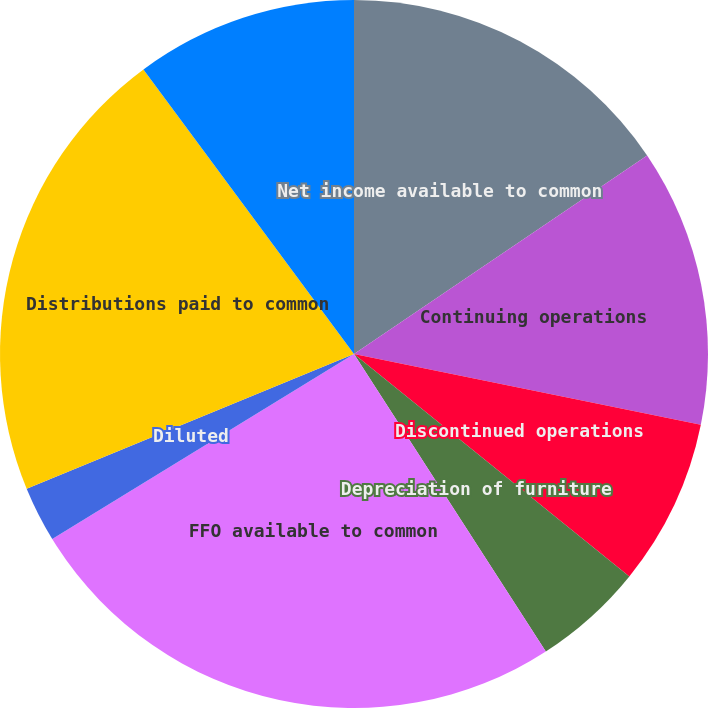<chart> <loc_0><loc_0><loc_500><loc_500><pie_chart><fcel>Net income available to common<fcel>Continuing operations<fcel>Discontinued operations<fcel>Depreciation of furniture<fcel>FFO available to common<fcel>Basic<fcel>Diluted<fcel>Distributions paid to common<fcel>FFO in excess of distributions<nl><fcel>15.53%<fcel>12.68%<fcel>7.61%<fcel>5.07%<fcel>25.36%<fcel>0.0%<fcel>2.54%<fcel>21.08%<fcel>10.14%<nl></chart> 